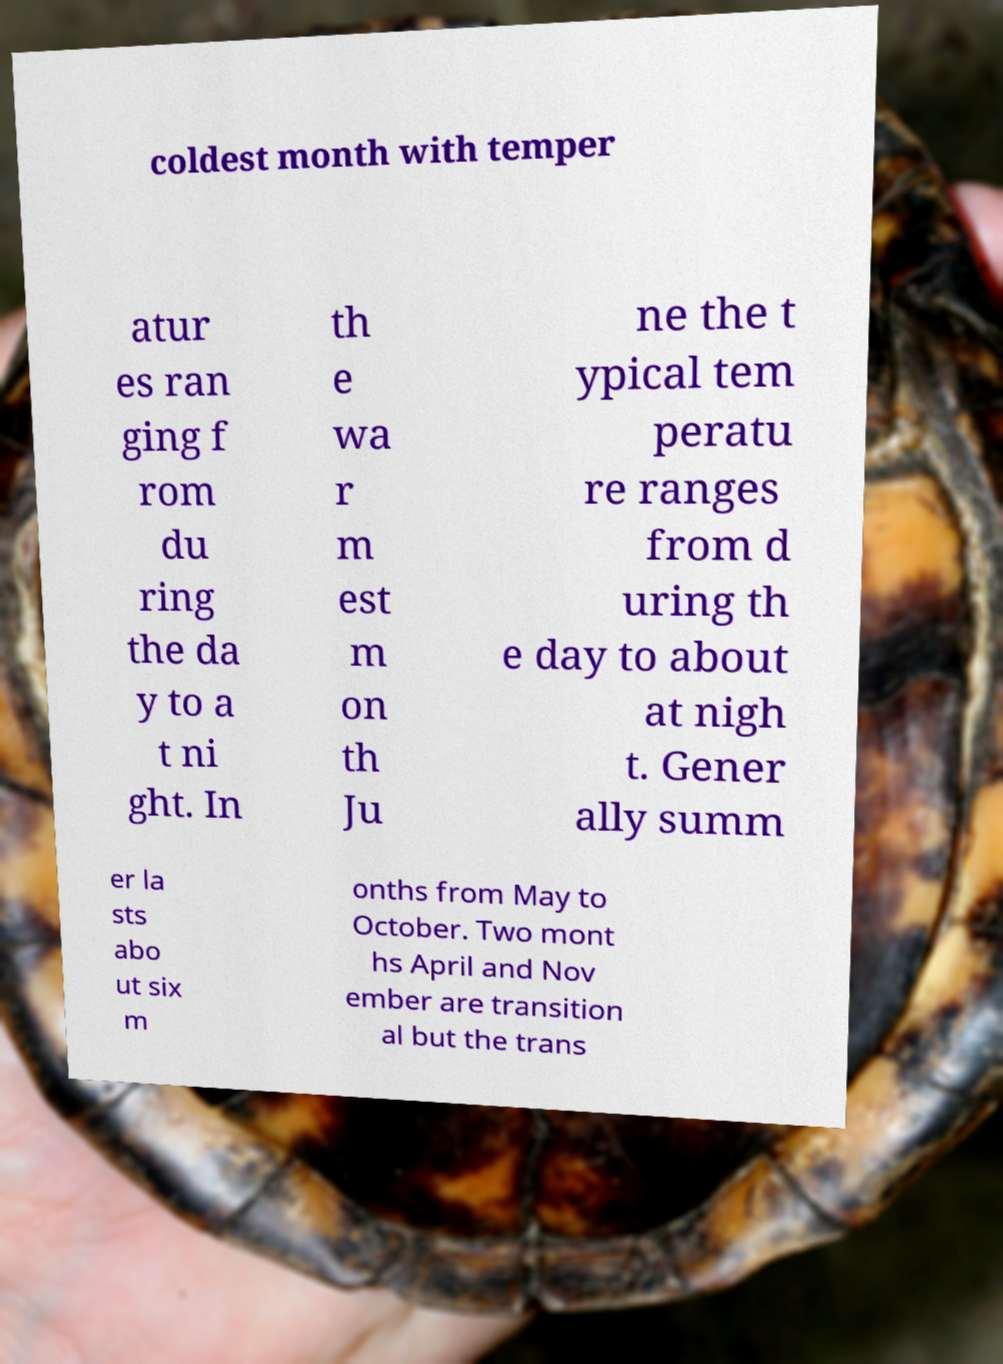Can you read and provide the text displayed in the image?This photo seems to have some interesting text. Can you extract and type it out for me? coldest month with temper atur es ran ging f rom du ring the da y to a t ni ght. In th e wa r m est m on th Ju ne the t ypical tem peratu re ranges from d uring th e day to about at nigh t. Gener ally summ er la sts abo ut six m onths from May to October. Two mont hs April and Nov ember are transition al but the trans 